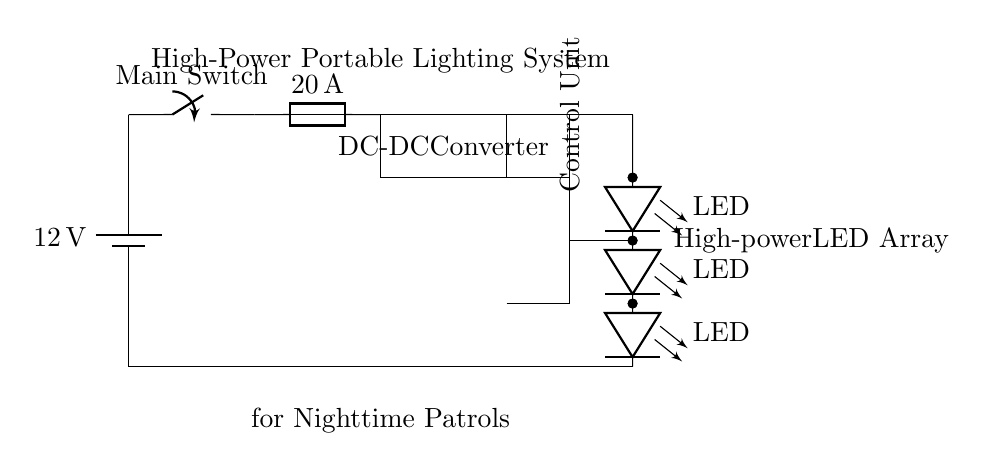What is the voltage of the battery? The battery is labeled with a voltage of 12 volts at the top left corner of the circuit diagram.
Answer: 12 volts What is the current rating of the fuse? The fuse is labeled with a current rating of 20 amps, located next to the fuse symbol in the circuit.
Answer: 20 amps What component converts the DC voltage? The component labeled as "DC-DC Converter" in the circuit diagram performs the conversion of DC voltage.
Answer: DC-DC Converter How many LEDs are in the array? The circuit shows a series of three LED symbols stacked vertically, indicating there are three LEDs in the array.
Answer: Three Which component controls the lights? The "Control Unit" labeled in the diagram is responsible for managing and controlling the lighting system.
Answer: Control Unit What is the purpose of the main switch? The main switch serves to turn the entire lighting system on or off, as indicated by its position at the start of the circuit near the battery.
Answer: To turn the system on/off How is the battery connected to the LED array? The battery is connected to the LED array through a series of components: the main switch, fuse, DC-DC converter, and the control unit, indicating a series connection.
Answer: Through a series connection 